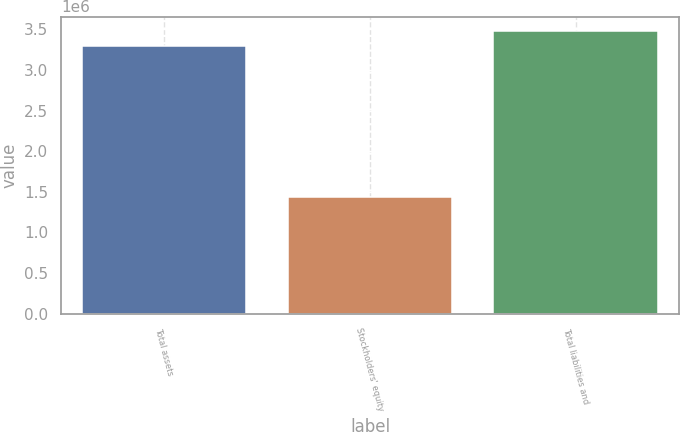Convert chart. <chart><loc_0><loc_0><loc_500><loc_500><bar_chart><fcel>Total assets<fcel>Stockholders' equity<fcel>Total liabilities and<nl><fcel>3.29567e+06<fcel>1.44063e+06<fcel>3.48117e+06<nl></chart> 